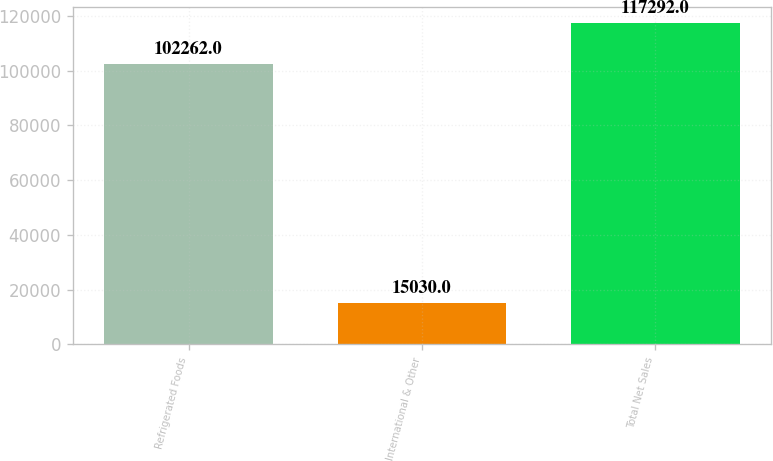Convert chart to OTSL. <chart><loc_0><loc_0><loc_500><loc_500><bar_chart><fcel>Refrigerated Foods<fcel>International & Other<fcel>Total Net Sales<nl><fcel>102262<fcel>15030<fcel>117292<nl></chart> 